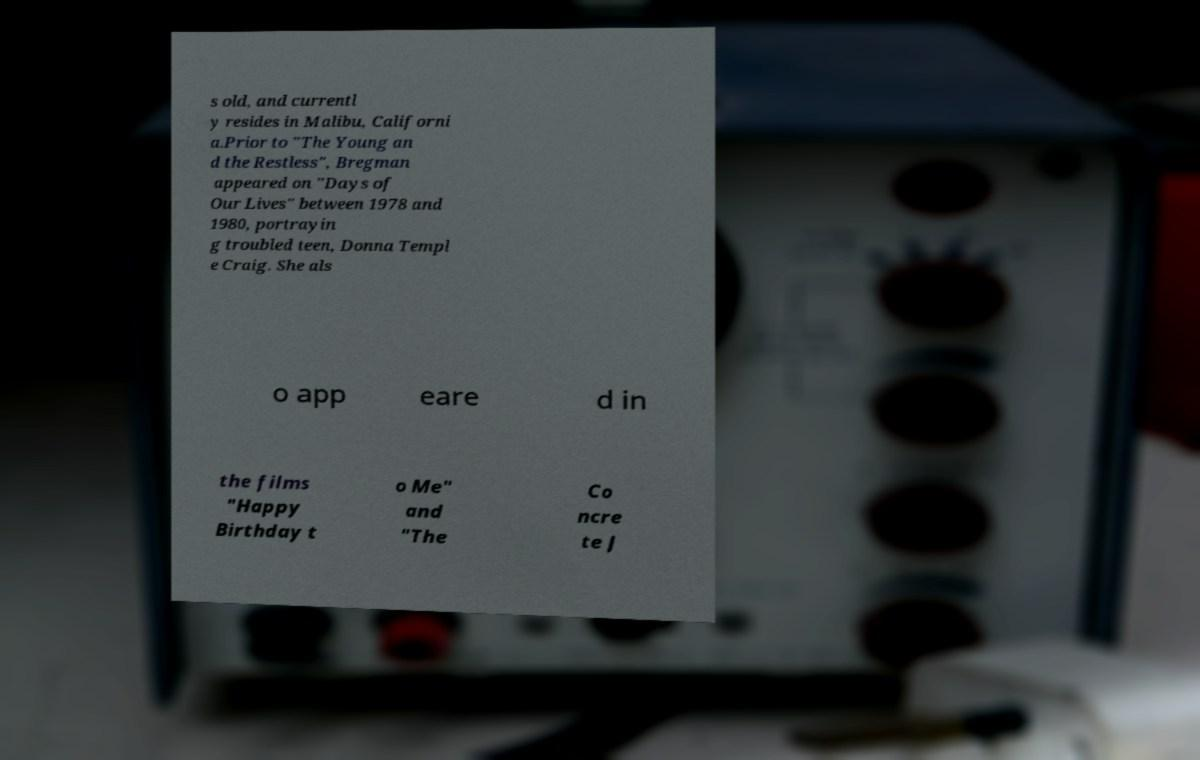I need the written content from this picture converted into text. Can you do that? s old, and currentl y resides in Malibu, Californi a.Prior to "The Young an d the Restless", Bregman appeared on "Days of Our Lives" between 1978 and 1980, portrayin g troubled teen, Donna Templ e Craig. She als o app eare d in the films "Happy Birthday t o Me" and "The Co ncre te J 